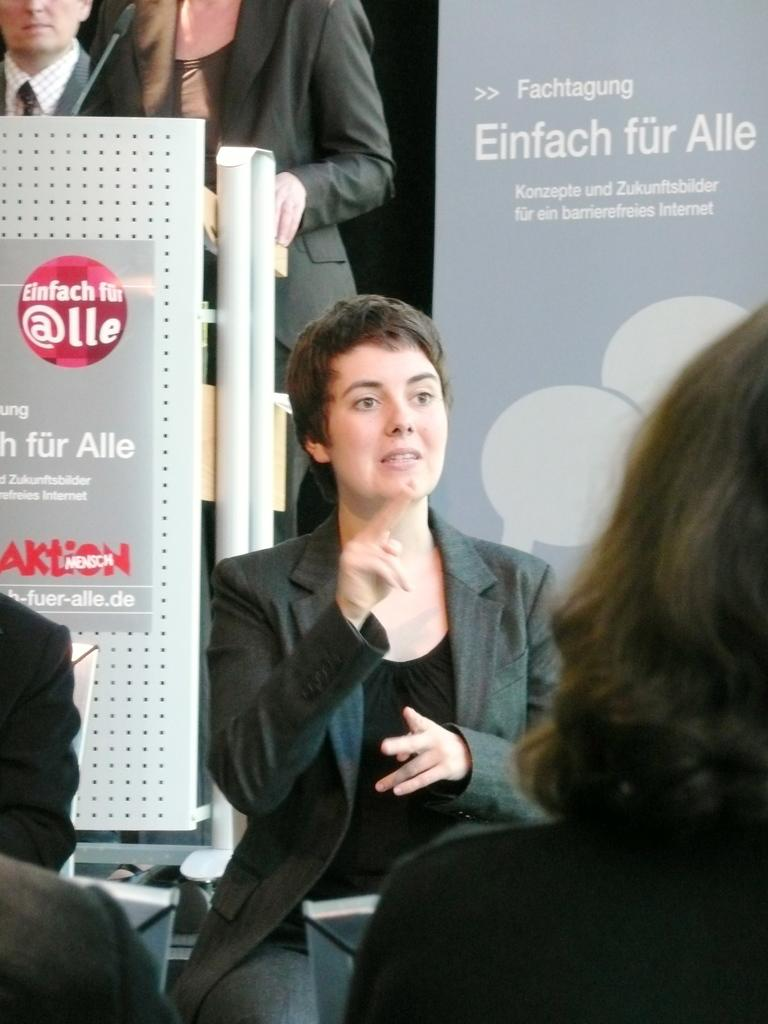What are the people in the image doing? The people in the image are sitting on chairs. What can be seen in the background of the image? There are posters in the background of the image. What is written on the posters? The posters have text on them. How many people are standing in the image? There are two persons standing in the image. What type of soup is being served in the image? There is no soup present in the image. How does the fire affect the people in the image? There is no fire present in the image, so it does not affect the people. 